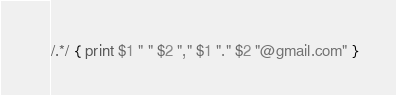Convert code to text. <code><loc_0><loc_0><loc_500><loc_500><_Awk_>/.*/ { print $1 " " $2 "," $1 "." $2 "@gmail.com" }
</code> 